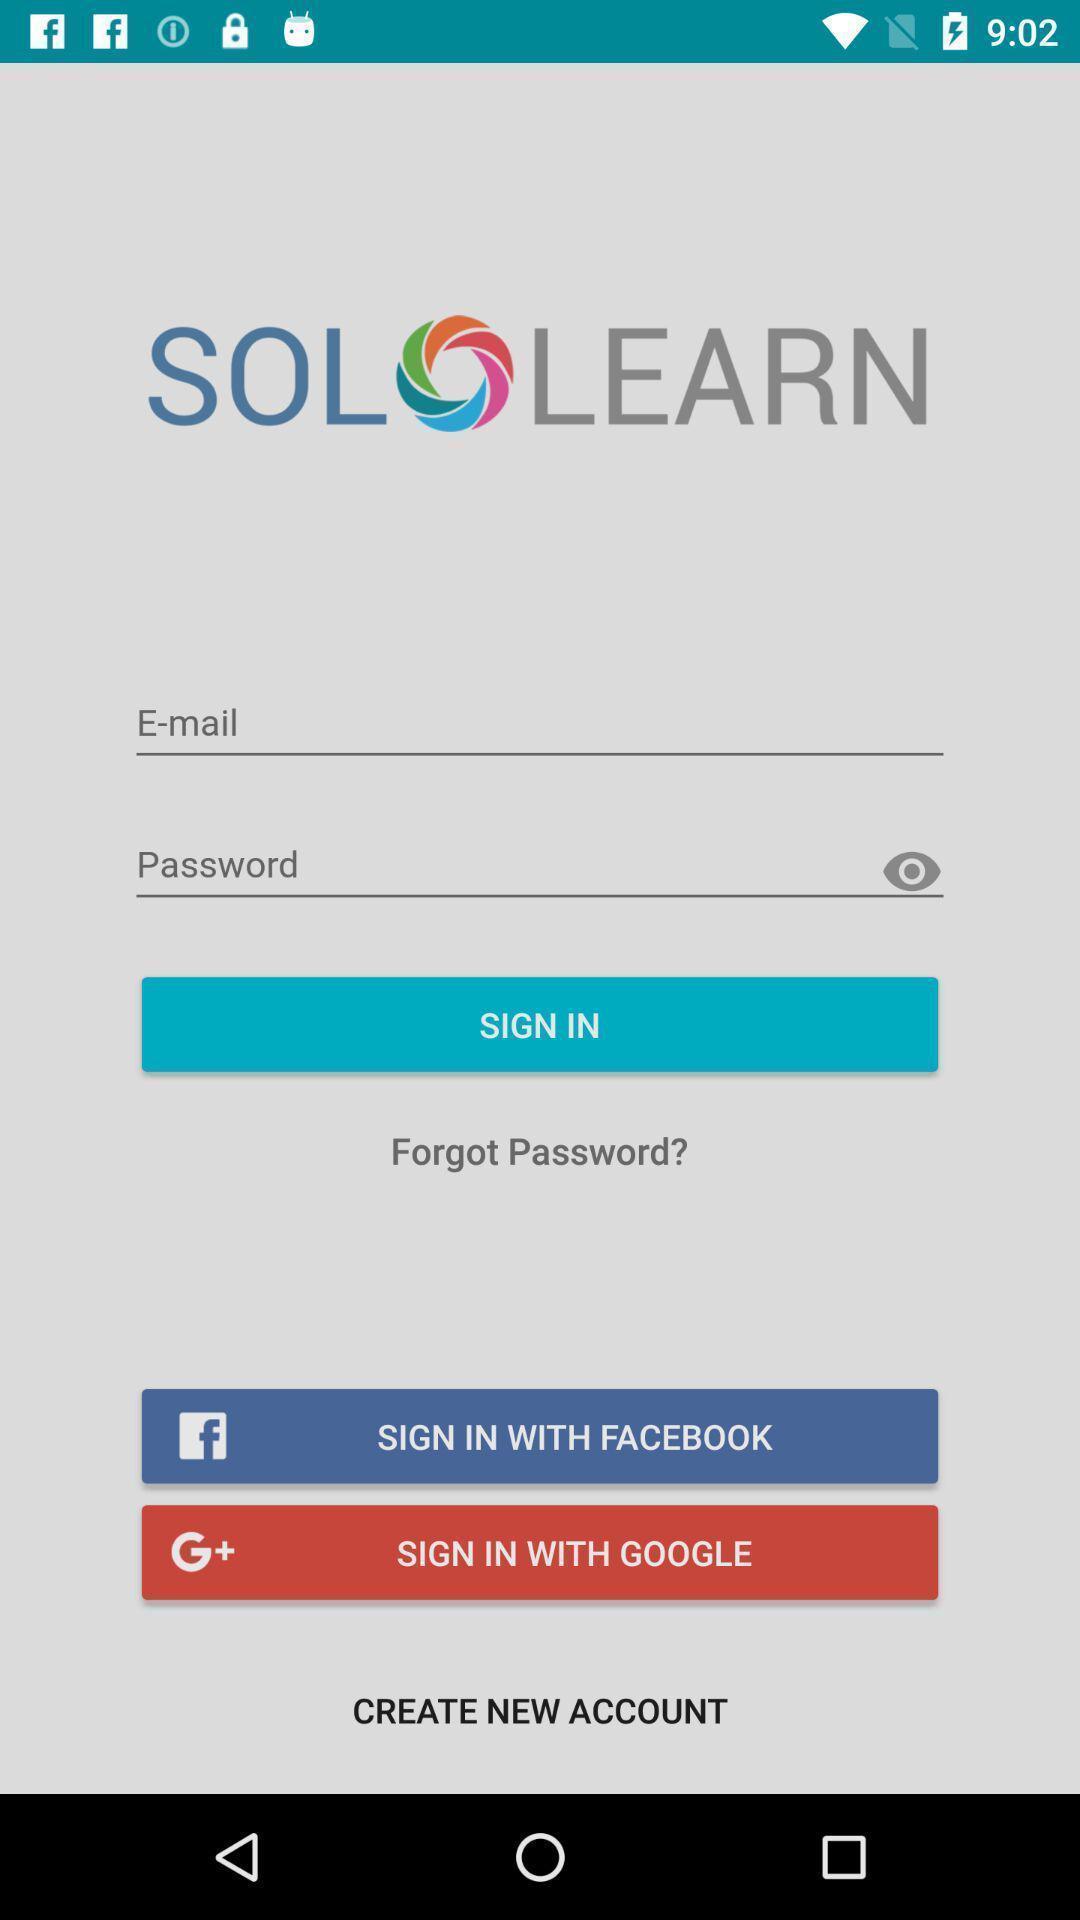Give me a narrative description of this picture. Sign in page of application to get access. 